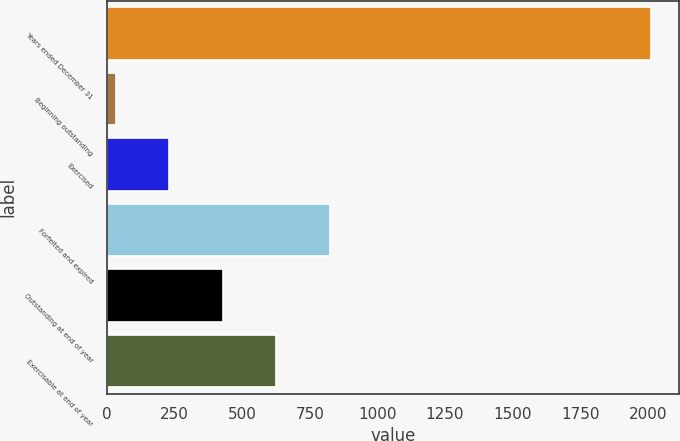Convert chart to OTSL. <chart><loc_0><loc_0><loc_500><loc_500><bar_chart><fcel>Years ended December 31<fcel>Beginning outstanding<fcel>Exercised<fcel>Forfeited and expired<fcel>Outstanding at end of year<fcel>Exercisable at end of year<nl><fcel>2013<fcel>32<fcel>230.1<fcel>824.4<fcel>428.2<fcel>626.3<nl></chart> 